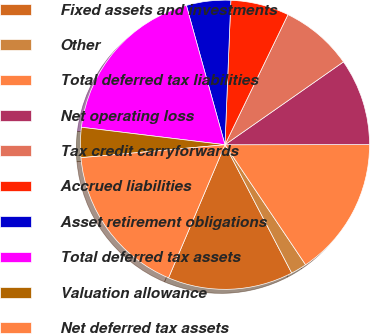Convert chart. <chart><loc_0><loc_0><loc_500><loc_500><pie_chart><fcel>Fixed assets and investments<fcel>Other<fcel>Total deferred tax liabilities<fcel>Net operating loss<fcel>Tax credit carryforwards<fcel>Accrued liabilities<fcel>Asset retirement obligations<fcel>Total deferred tax assets<fcel>Valuation allowance<fcel>Net deferred tax assets<nl><fcel>14.02%<fcel>1.78%<fcel>15.6%<fcel>9.7%<fcel>8.11%<fcel>6.53%<fcel>4.95%<fcel>18.77%<fcel>3.36%<fcel>17.19%<nl></chart> 